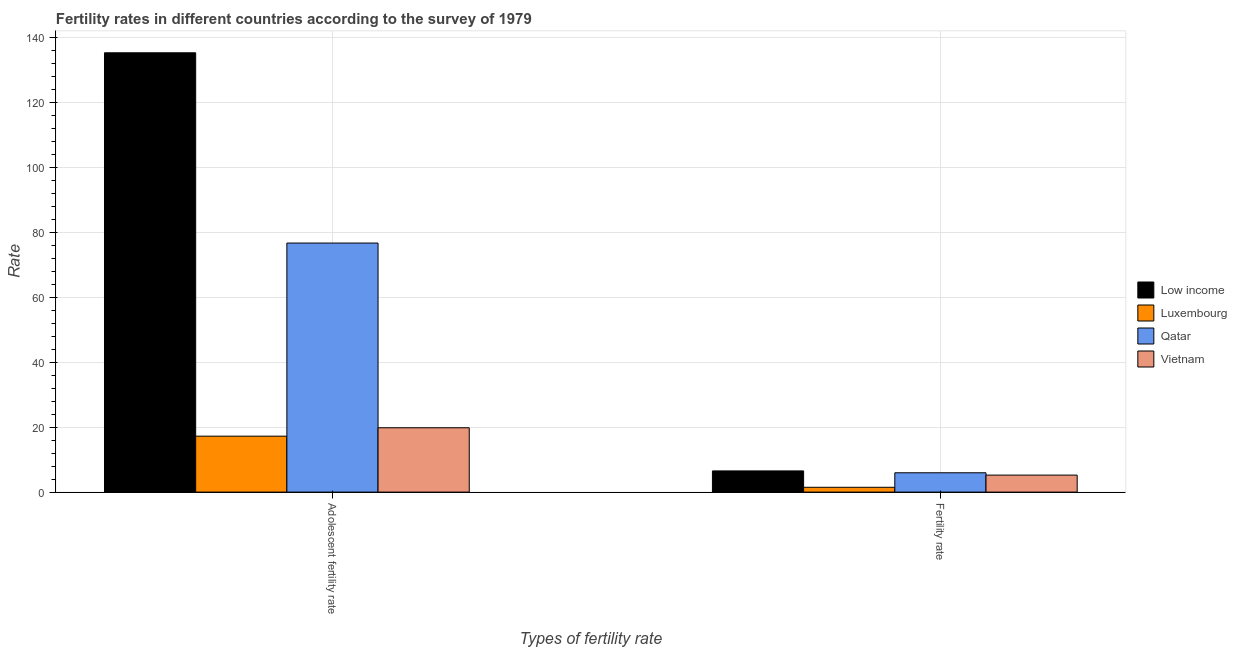How many different coloured bars are there?
Your response must be concise. 4. How many groups of bars are there?
Your response must be concise. 2. Are the number of bars per tick equal to the number of legend labels?
Give a very brief answer. Yes. Are the number of bars on each tick of the X-axis equal?
Offer a very short reply. Yes. How many bars are there on the 1st tick from the right?
Make the answer very short. 4. What is the label of the 2nd group of bars from the left?
Give a very brief answer. Fertility rate. What is the adolescent fertility rate in Qatar?
Keep it short and to the point. 76.63. Across all countries, what is the maximum adolescent fertility rate?
Your answer should be compact. 135.16. Across all countries, what is the minimum fertility rate?
Ensure brevity in your answer.  1.48. In which country was the adolescent fertility rate maximum?
Your response must be concise. Low income. In which country was the fertility rate minimum?
Your answer should be compact. Luxembourg. What is the total adolescent fertility rate in the graph?
Your response must be concise. 248.8. What is the difference between the fertility rate in Vietnam and that in Qatar?
Your answer should be very brief. -0.71. What is the difference between the fertility rate in Luxembourg and the adolescent fertility rate in Qatar?
Make the answer very short. -75.15. What is the average fertility rate per country?
Provide a succinct answer. 4.79. What is the difference between the fertility rate and adolescent fertility rate in Luxembourg?
Provide a short and direct response. -15.73. In how many countries, is the adolescent fertility rate greater than 20 ?
Make the answer very short. 2. What is the ratio of the fertility rate in Luxembourg to that in Low income?
Your response must be concise. 0.23. What does the 3rd bar from the left in Fertility rate represents?
Ensure brevity in your answer.  Qatar. What does the 1st bar from the right in Fertility rate represents?
Offer a terse response. Vietnam. How many bars are there?
Your answer should be very brief. 8. How many countries are there in the graph?
Your response must be concise. 4. What is the difference between two consecutive major ticks on the Y-axis?
Your response must be concise. 20. Are the values on the major ticks of Y-axis written in scientific E-notation?
Keep it short and to the point. No. Does the graph contain any zero values?
Offer a very short reply. No. Where does the legend appear in the graph?
Make the answer very short. Center right. What is the title of the graph?
Keep it short and to the point. Fertility rates in different countries according to the survey of 1979. What is the label or title of the X-axis?
Give a very brief answer. Types of fertility rate. What is the label or title of the Y-axis?
Ensure brevity in your answer.  Rate. What is the Rate in Low income in Adolescent fertility rate?
Offer a terse response. 135.16. What is the Rate in Luxembourg in Adolescent fertility rate?
Keep it short and to the point. 17.21. What is the Rate in Qatar in Adolescent fertility rate?
Give a very brief answer. 76.63. What is the Rate of Vietnam in Adolescent fertility rate?
Ensure brevity in your answer.  19.8. What is the Rate in Low income in Fertility rate?
Offer a terse response. 6.52. What is the Rate of Luxembourg in Fertility rate?
Provide a succinct answer. 1.48. What is the Rate in Qatar in Fertility rate?
Your response must be concise. 5.95. What is the Rate of Vietnam in Fertility rate?
Your response must be concise. 5.23. Across all Types of fertility rate, what is the maximum Rate of Low income?
Your answer should be very brief. 135.16. Across all Types of fertility rate, what is the maximum Rate in Luxembourg?
Your answer should be compact. 17.21. Across all Types of fertility rate, what is the maximum Rate of Qatar?
Offer a very short reply. 76.63. Across all Types of fertility rate, what is the maximum Rate in Vietnam?
Provide a succinct answer. 19.8. Across all Types of fertility rate, what is the minimum Rate in Low income?
Offer a very short reply. 6.52. Across all Types of fertility rate, what is the minimum Rate of Luxembourg?
Keep it short and to the point. 1.48. Across all Types of fertility rate, what is the minimum Rate of Qatar?
Offer a terse response. 5.95. Across all Types of fertility rate, what is the minimum Rate of Vietnam?
Your answer should be very brief. 5.23. What is the total Rate of Low income in the graph?
Your response must be concise. 141.68. What is the total Rate of Luxembourg in the graph?
Your answer should be very brief. 18.69. What is the total Rate in Qatar in the graph?
Ensure brevity in your answer.  82.57. What is the total Rate of Vietnam in the graph?
Give a very brief answer. 25.03. What is the difference between the Rate of Low income in Adolescent fertility rate and that in Fertility rate?
Provide a short and direct response. 128.65. What is the difference between the Rate of Luxembourg in Adolescent fertility rate and that in Fertility rate?
Give a very brief answer. 15.73. What is the difference between the Rate in Qatar in Adolescent fertility rate and that in Fertility rate?
Make the answer very short. 70.68. What is the difference between the Rate in Vietnam in Adolescent fertility rate and that in Fertility rate?
Offer a terse response. 14.56. What is the difference between the Rate in Low income in Adolescent fertility rate and the Rate in Luxembourg in Fertility rate?
Ensure brevity in your answer.  133.68. What is the difference between the Rate in Low income in Adolescent fertility rate and the Rate in Qatar in Fertility rate?
Provide a succinct answer. 129.22. What is the difference between the Rate in Low income in Adolescent fertility rate and the Rate in Vietnam in Fertility rate?
Provide a short and direct response. 129.93. What is the difference between the Rate of Luxembourg in Adolescent fertility rate and the Rate of Qatar in Fertility rate?
Your answer should be compact. 11.27. What is the difference between the Rate in Luxembourg in Adolescent fertility rate and the Rate in Vietnam in Fertility rate?
Give a very brief answer. 11.98. What is the difference between the Rate of Qatar in Adolescent fertility rate and the Rate of Vietnam in Fertility rate?
Your answer should be very brief. 71.39. What is the average Rate in Low income per Types of fertility rate?
Make the answer very short. 70.84. What is the average Rate in Luxembourg per Types of fertility rate?
Your answer should be compact. 9.35. What is the average Rate in Qatar per Types of fertility rate?
Your response must be concise. 41.29. What is the average Rate of Vietnam per Types of fertility rate?
Provide a short and direct response. 12.51. What is the difference between the Rate of Low income and Rate of Luxembourg in Adolescent fertility rate?
Make the answer very short. 117.95. What is the difference between the Rate in Low income and Rate in Qatar in Adolescent fertility rate?
Offer a terse response. 58.54. What is the difference between the Rate of Low income and Rate of Vietnam in Adolescent fertility rate?
Your answer should be compact. 115.37. What is the difference between the Rate of Luxembourg and Rate of Qatar in Adolescent fertility rate?
Provide a short and direct response. -59.41. What is the difference between the Rate in Luxembourg and Rate in Vietnam in Adolescent fertility rate?
Offer a terse response. -2.58. What is the difference between the Rate in Qatar and Rate in Vietnam in Adolescent fertility rate?
Give a very brief answer. 56.83. What is the difference between the Rate in Low income and Rate in Luxembourg in Fertility rate?
Ensure brevity in your answer.  5.04. What is the difference between the Rate of Low income and Rate of Qatar in Fertility rate?
Provide a short and direct response. 0.57. What is the difference between the Rate of Low income and Rate of Vietnam in Fertility rate?
Give a very brief answer. 1.29. What is the difference between the Rate of Luxembourg and Rate of Qatar in Fertility rate?
Your response must be concise. -4.47. What is the difference between the Rate of Luxembourg and Rate of Vietnam in Fertility rate?
Make the answer very short. -3.75. What is the difference between the Rate of Qatar and Rate of Vietnam in Fertility rate?
Give a very brief answer. 0.71. What is the ratio of the Rate in Low income in Adolescent fertility rate to that in Fertility rate?
Provide a succinct answer. 20.74. What is the ratio of the Rate of Luxembourg in Adolescent fertility rate to that in Fertility rate?
Make the answer very short. 11.63. What is the ratio of the Rate of Qatar in Adolescent fertility rate to that in Fertility rate?
Provide a succinct answer. 12.88. What is the ratio of the Rate in Vietnam in Adolescent fertility rate to that in Fertility rate?
Ensure brevity in your answer.  3.78. What is the difference between the highest and the second highest Rate of Low income?
Provide a succinct answer. 128.65. What is the difference between the highest and the second highest Rate in Luxembourg?
Your answer should be very brief. 15.73. What is the difference between the highest and the second highest Rate of Qatar?
Your answer should be very brief. 70.68. What is the difference between the highest and the second highest Rate in Vietnam?
Provide a short and direct response. 14.56. What is the difference between the highest and the lowest Rate of Low income?
Offer a very short reply. 128.65. What is the difference between the highest and the lowest Rate in Luxembourg?
Your answer should be compact. 15.73. What is the difference between the highest and the lowest Rate in Qatar?
Ensure brevity in your answer.  70.68. What is the difference between the highest and the lowest Rate of Vietnam?
Ensure brevity in your answer.  14.56. 